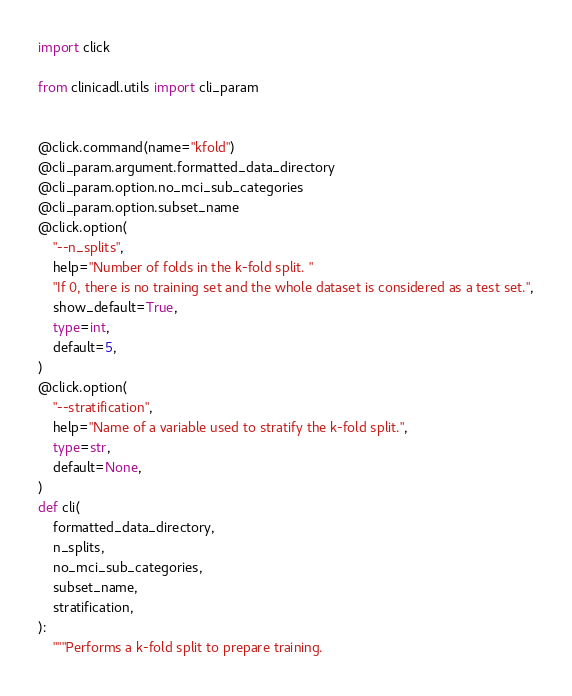<code> <loc_0><loc_0><loc_500><loc_500><_Python_>import click

from clinicadl.utils import cli_param


@click.command(name="kfold")
@cli_param.argument.formatted_data_directory
@cli_param.option.no_mci_sub_categories
@cli_param.option.subset_name
@click.option(
    "--n_splits",
    help="Number of folds in the k-fold split. "
    "If 0, there is no training set and the whole dataset is considered as a test set.",
    show_default=True,
    type=int,
    default=5,
)
@click.option(
    "--stratification",
    help="Name of a variable used to stratify the k-fold split.",
    type=str,
    default=None,
)
def cli(
    formatted_data_directory,
    n_splits,
    no_mci_sub_categories,
    subset_name,
    stratification,
):
    """Performs a k-fold split to prepare training.
</code> 